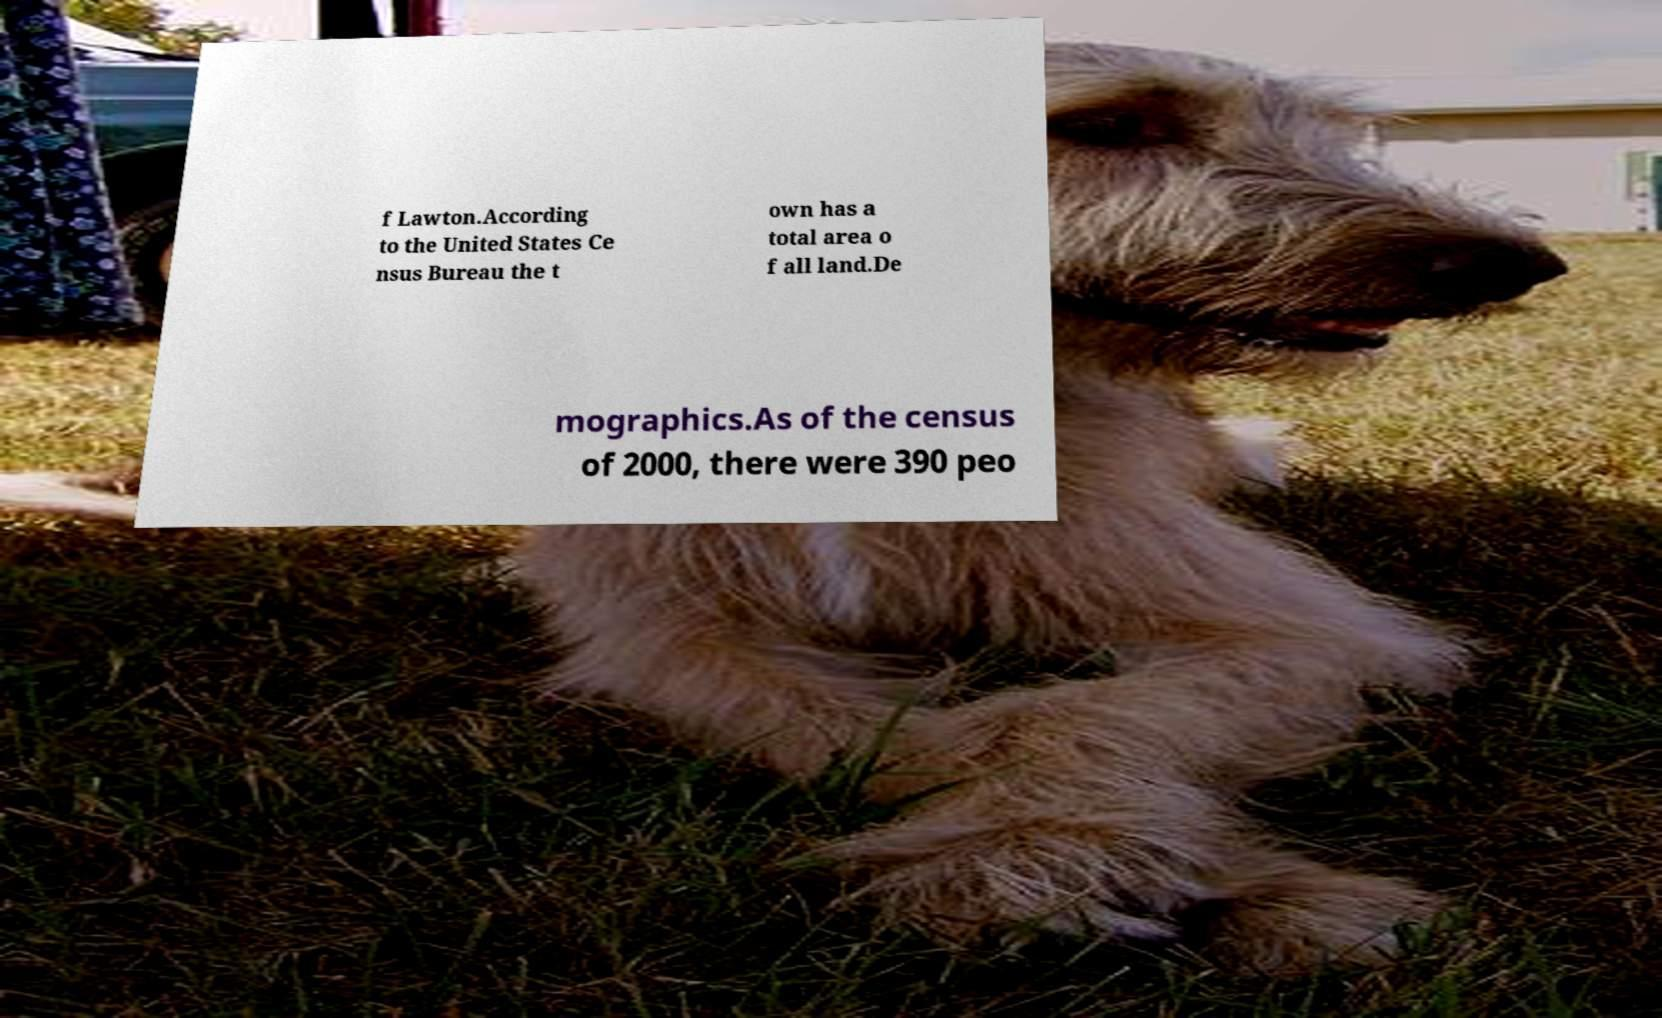Can you accurately transcribe the text from the provided image for me? f Lawton.According to the United States Ce nsus Bureau the t own has a total area o f all land.De mographics.As of the census of 2000, there were 390 peo 